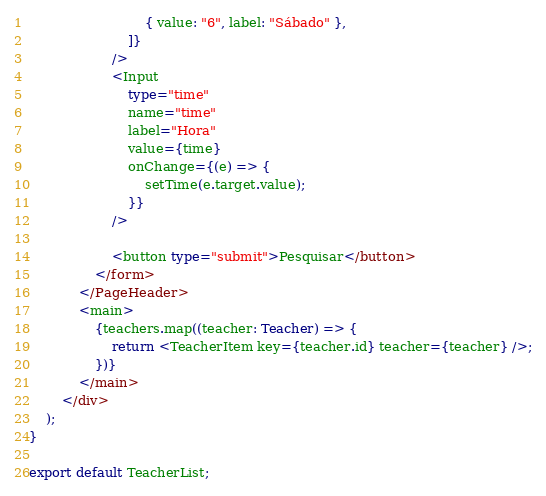<code> <loc_0><loc_0><loc_500><loc_500><_TypeScript_>                            { value: "6", label: "Sábado" },
                        ]}
                    />
                    <Input
                        type="time"
                        name="time"
                        label="Hora"
                        value={time}
                        onChange={(e) => {
                            setTime(e.target.value);
                        }}
                    />

                    <button type="submit">Pesquisar</button>
                </form>
            </PageHeader>
            <main>
                {teachers.map((teacher: Teacher) => {
                    return <TeacherItem key={teacher.id} teacher={teacher} />;
                })}
            </main>
        </div>
    );
}

export default TeacherList;
</code> 